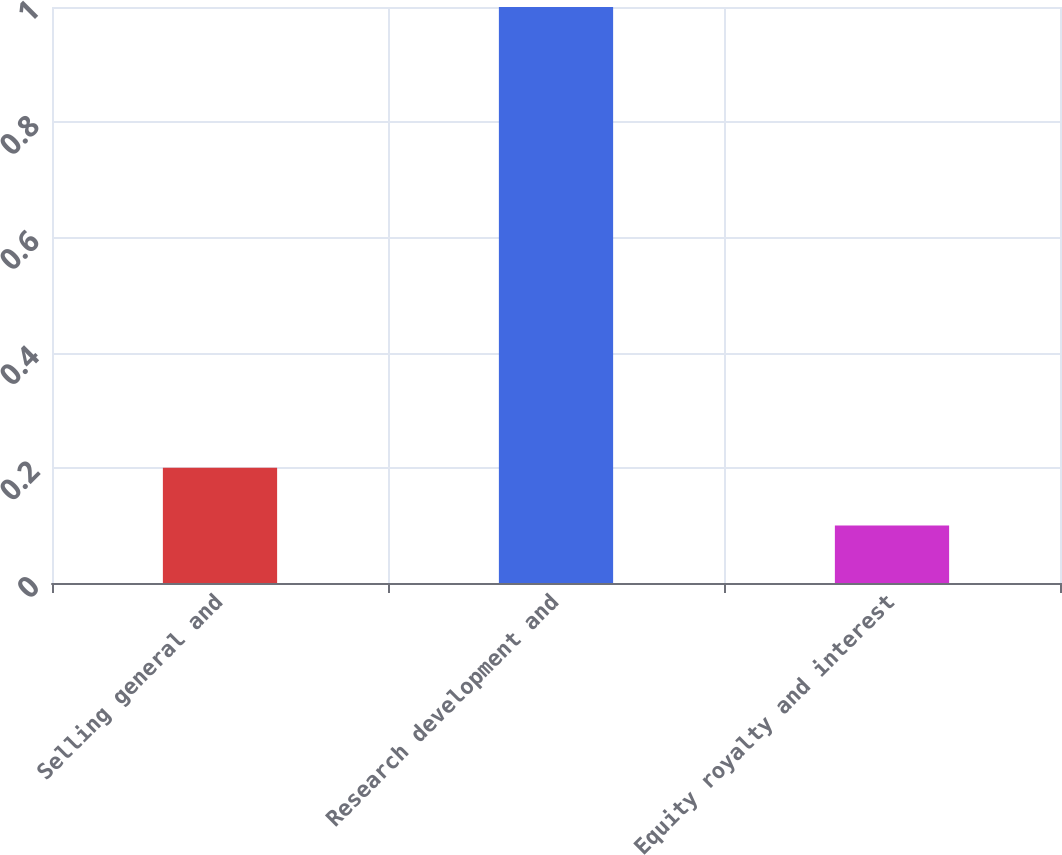<chart> <loc_0><loc_0><loc_500><loc_500><bar_chart><fcel>Selling general and<fcel>Research development and<fcel>Equity royalty and interest<nl><fcel>0.2<fcel>1<fcel>0.1<nl></chart> 